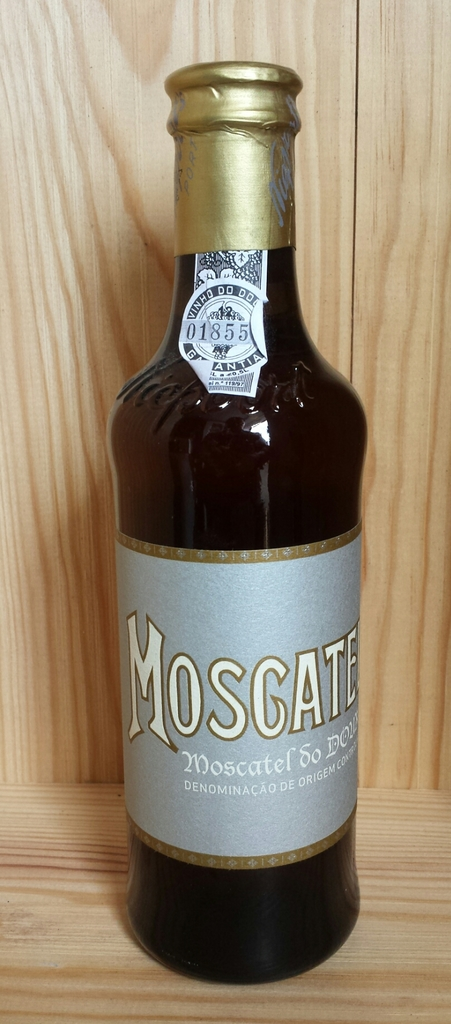Can you describe the aesthetic characteristics of this Moscatel bottle's design? The Moscatel bottle features an elegant design with a sleek, dark glass body complemented by a luxurious gold foil neck and a meticulously designed label. The label combines classic script and clean modern lines, creating a stylish blend of tradition and contemporary appeal. 